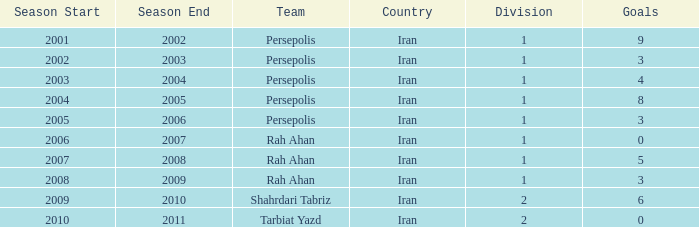What is the sum of Goals, when Season is "2005-06", and when Division is less than 1? None. 